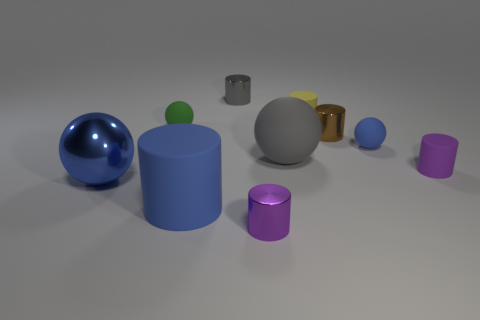Is the size of the yellow object the same as the blue cylinder?
Give a very brief answer. No. Is there any other thing that is the same shape as the green rubber thing?
Make the answer very short. Yes. How many things are tiny spheres that are to the right of the green thing or small green matte spheres?
Ensure brevity in your answer.  2. Is the tiny purple shiny object the same shape as the tiny yellow object?
Make the answer very short. Yes. What number of other objects are the same size as the green rubber object?
Make the answer very short. 6. What is the color of the big metallic thing?
Your answer should be compact. Blue. How many small objects are yellow objects or balls?
Offer a very short reply. 3. There is a blue thing right of the big gray rubber thing; is its size the same as the cylinder on the left side of the gray metallic cylinder?
Your answer should be very brief. No. There is a gray rubber object that is the same shape as the small blue thing; what size is it?
Keep it short and to the point. Large. Is the number of tiny shiny objects behind the tiny yellow rubber thing greater than the number of small purple things that are right of the gray sphere?
Ensure brevity in your answer.  No. 